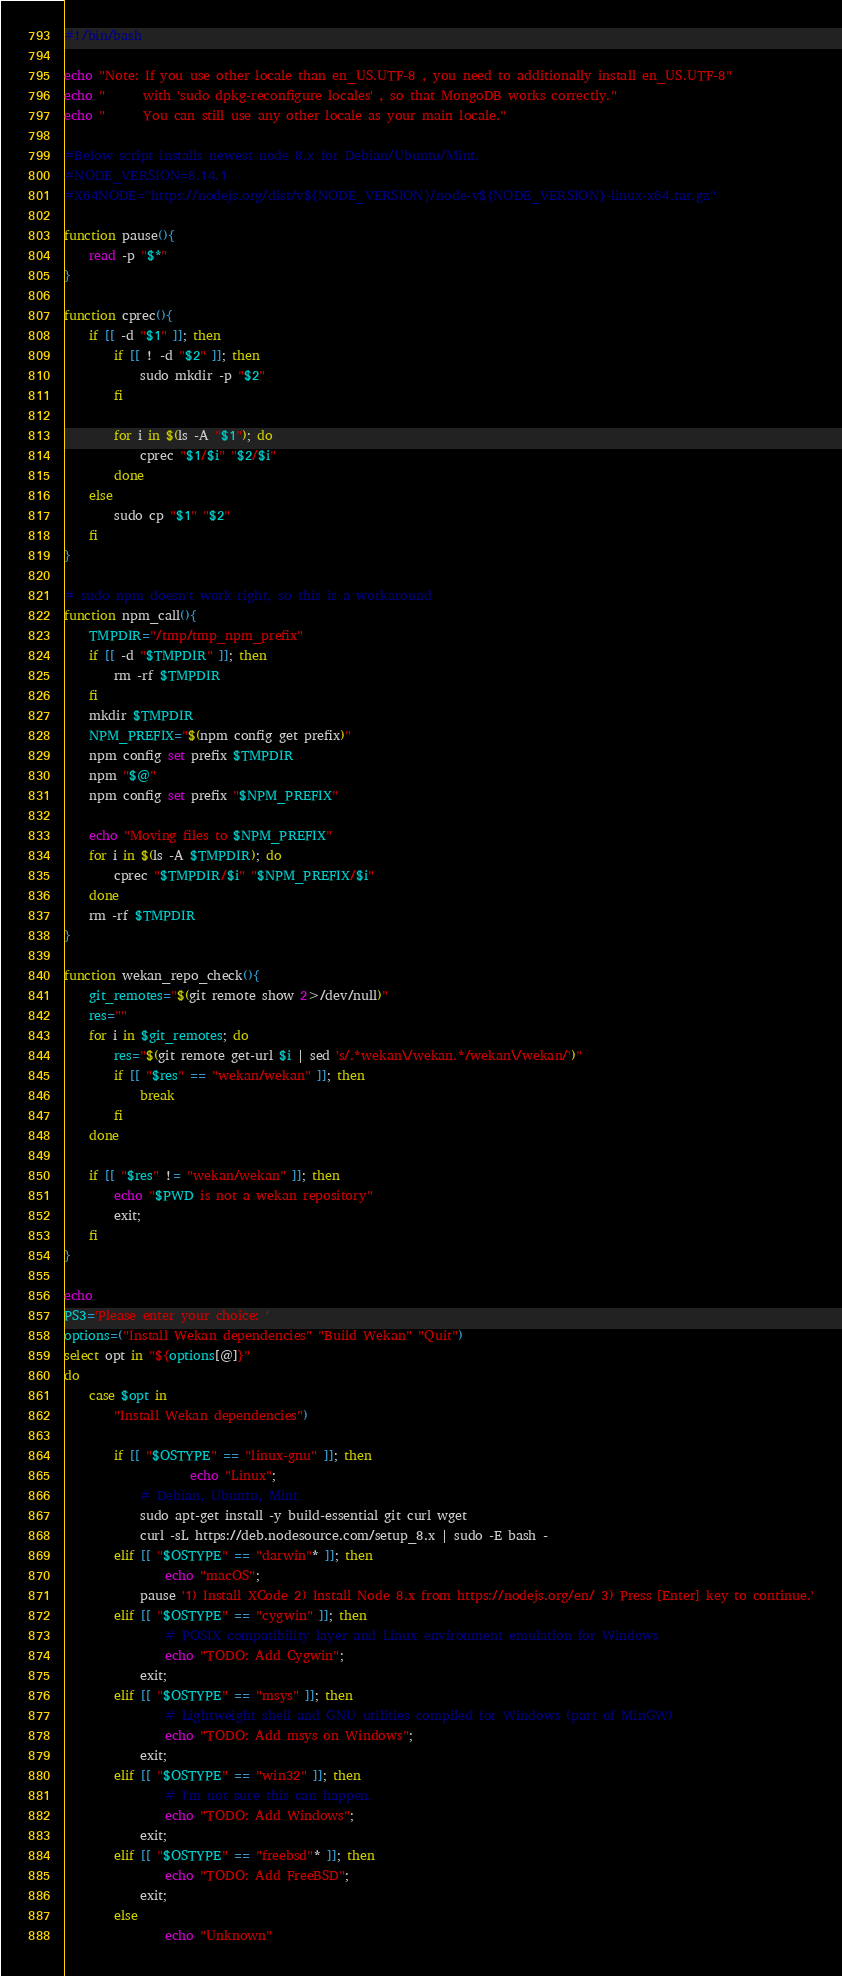<code> <loc_0><loc_0><loc_500><loc_500><_Bash_>#!/bin/bash

echo "Note: If you use other locale than en_US.UTF-8 , you need to additionally install en_US.UTF-8"
echo "      with 'sudo dpkg-reconfigure locales' , so that MongoDB works correctly."
echo "      You can still use any other locale as your main locale."

#Below script installs newest node 8.x for Debian/Ubuntu/Mint.
#NODE_VERSION=8.14.1
#X64NODE="https://nodejs.org/dist/v${NODE_VERSION}/node-v${NODE_VERSION}-linux-x64.tar.gz"

function pause(){
	read -p "$*"
}

function cprec(){
	if [[ -d "$1" ]]; then
		if [[ ! -d "$2" ]]; then
			sudo mkdir -p "$2"
		fi

		for i in $(ls -A "$1"); do
			cprec "$1/$i" "$2/$i"
		done
	else
		sudo cp "$1" "$2"
	fi
}

# sudo npm doesn't work right, so this is a workaround
function npm_call(){
	TMPDIR="/tmp/tmp_npm_prefix"
	if [[ -d "$TMPDIR" ]]; then
		rm -rf $TMPDIR
	fi
	mkdir $TMPDIR
	NPM_PREFIX="$(npm config get prefix)"
	npm config set prefix $TMPDIR
	npm "$@"
	npm config set prefix "$NPM_PREFIX"

	echo "Moving files to $NPM_PREFIX"
	for i in $(ls -A $TMPDIR); do
		cprec "$TMPDIR/$i" "$NPM_PREFIX/$i"
	done
	rm -rf $TMPDIR
}

function wekan_repo_check(){
	git_remotes="$(git remote show 2>/dev/null)"
	res=""
	for i in $git_remotes; do
		res="$(git remote get-url $i | sed 's/.*wekan\/wekan.*/wekan\/wekan/')"
		if [[ "$res" == "wekan/wekan" ]]; then
		    break
		fi
	done

	if [[ "$res" != "wekan/wekan" ]]; then
		echo "$PWD is not a wekan repository"
		exit;
	fi
}

echo
PS3='Please enter your choice: '
options=("Install Wekan dependencies" "Build Wekan" "Quit")
select opt in "${options[@]}"
do
    case $opt in
        "Install Wekan dependencies")

		if [[ "$OSTYPE" == "linux-gnu" ]]; then
	                echo "Linux";
			# Debian, Ubuntu, Mint
			sudo apt-get install -y build-essential git curl wget
			curl -sL https://deb.nodesource.com/setup_8.x | sudo -E bash -
		elif [[ "$OSTYPE" == "darwin"* ]]; then
		        echo "macOS";
			pause '1) Install XCode 2) Install Node 8.x from https://nodejs.org/en/ 3) Press [Enter] key to continue.'
		elif [[ "$OSTYPE" == "cygwin" ]]; then
		        # POSIX compatibility layer and Linux environment emulation for Windows
		        echo "TODO: Add Cygwin";
			exit;
		elif [[ "$OSTYPE" == "msys" ]]; then
		        # Lightweight shell and GNU utilities compiled for Windows (part of MinGW)
		        echo "TODO: Add msys on Windows";
			exit;
		elif [[ "$OSTYPE" == "win32" ]]; then
		        # I'm not sure this can happen.
		        echo "TODO: Add Windows";
			exit;
		elif [[ "$OSTYPE" == "freebsd"* ]]; then
		        echo "TODO: Add FreeBSD";
			exit;
		else
		        echo "Unknown"</code> 